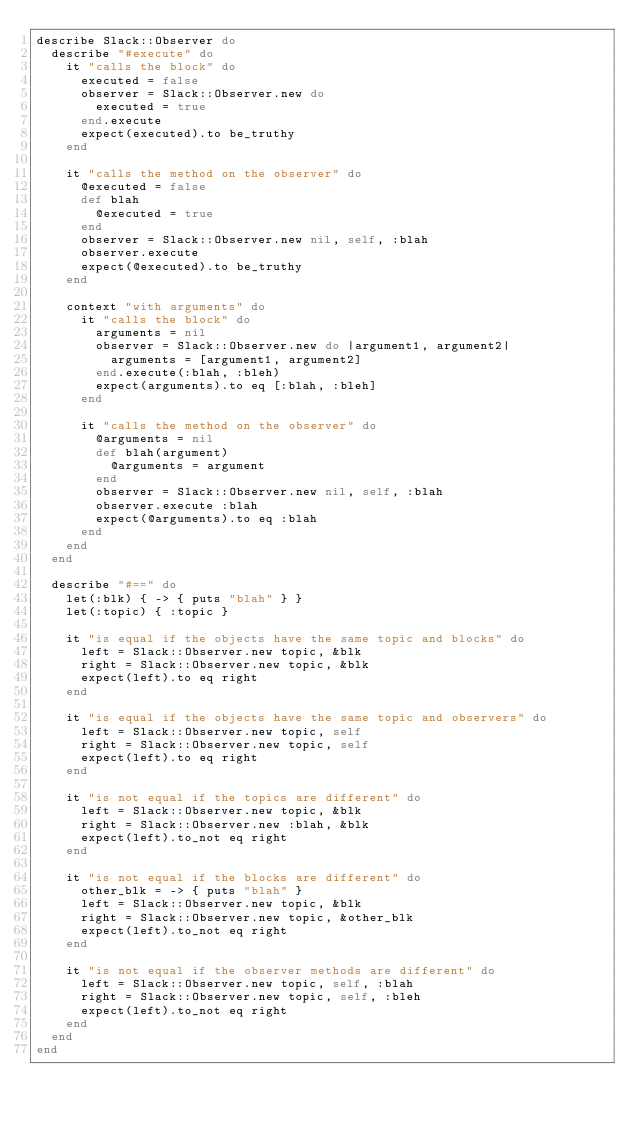<code> <loc_0><loc_0><loc_500><loc_500><_Ruby_>describe Slack::Observer do
  describe "#execute" do
    it "calls the block" do
      executed = false
      observer = Slack::Observer.new do
        executed = true
      end.execute
      expect(executed).to be_truthy
    end

    it "calls the method on the observer" do
      @executed = false
      def blah
        @executed = true
      end
      observer = Slack::Observer.new nil, self, :blah
      observer.execute
      expect(@executed).to be_truthy
    end

    context "with arguments" do
      it "calls the block" do
        arguments = nil
        observer = Slack::Observer.new do |argument1, argument2|
          arguments = [argument1, argument2]
        end.execute(:blah, :bleh)
        expect(arguments).to eq [:blah, :bleh]
      end

      it "calls the method on the observer" do
        @arguments = nil
        def blah(argument)
          @arguments = argument
        end
        observer = Slack::Observer.new nil, self, :blah
        observer.execute :blah
        expect(@arguments).to eq :blah
      end
    end
  end

  describe "#==" do
    let(:blk) { -> { puts "blah" } }
    let(:topic) { :topic }

    it "is equal if the objects have the same topic and blocks" do
      left = Slack::Observer.new topic, &blk
      right = Slack::Observer.new topic, &blk
      expect(left).to eq right
    end

    it "is equal if the objects have the same topic and observers" do
      left = Slack::Observer.new topic, self
      right = Slack::Observer.new topic, self
      expect(left).to eq right
    end

    it "is not equal if the topics are different" do
      left = Slack::Observer.new topic, &blk
      right = Slack::Observer.new :blah, &blk
      expect(left).to_not eq right
    end

    it "is not equal if the blocks are different" do
      other_blk = -> { puts "blah" }
      left = Slack::Observer.new topic, &blk
      right = Slack::Observer.new topic, &other_blk
      expect(left).to_not eq right
    end

    it "is not equal if the observer methods are different" do
      left = Slack::Observer.new topic, self, :blah
      right = Slack::Observer.new topic, self, :bleh
      expect(left).to_not eq right
    end
  end
end
</code> 